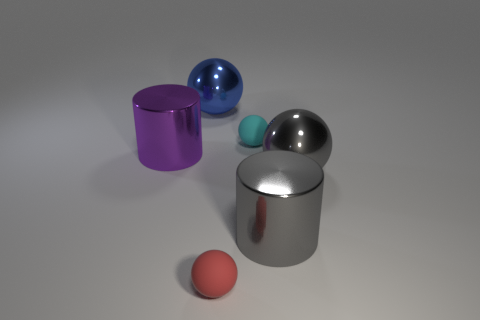What shape is the small object behind the large gray object behind the large metallic cylinder to the right of the small red ball?
Your response must be concise. Sphere. Is the number of tiny spheres that are behind the tiny red matte thing greater than the number of cyan balls that are on the right side of the tiny cyan ball?
Your answer should be compact. Yes. Are there any balls left of the large gray cylinder?
Your answer should be compact. Yes. What is the material of the thing that is in front of the big blue sphere and left of the small red thing?
Make the answer very short. Metal. The other big thing that is the same shape as the big purple thing is what color?
Keep it short and to the point. Gray. Is there a blue shiny object in front of the small rubber sphere that is in front of the big gray cylinder?
Keep it short and to the point. No. The red matte ball is what size?
Offer a terse response. Small. There is a big shiny thing that is both right of the blue metal thing and behind the gray metallic cylinder; what is its shape?
Make the answer very short. Sphere. How many blue objects are tiny balls or large balls?
Make the answer very short. 1. There is a metallic sphere behind the purple shiny cylinder; is it the same size as the shiny thing that is to the left of the large blue ball?
Ensure brevity in your answer.  Yes. 